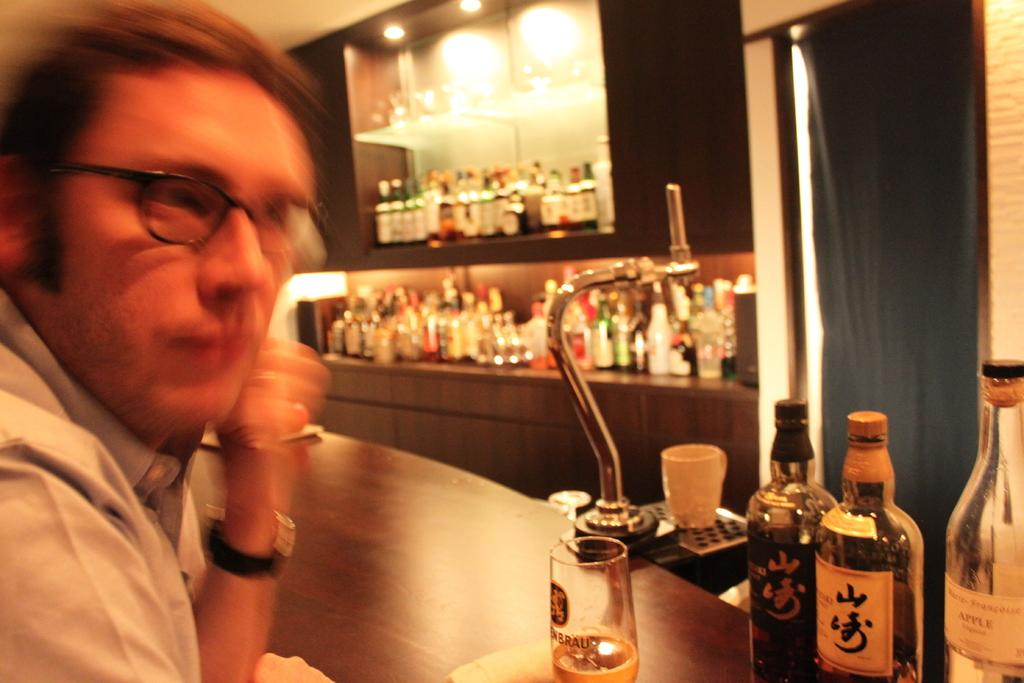What is the person in the image doing? The person is sitting in front of a table. What items can be seen on the table? There are wine bottles and a glass on the table. Are there any other wine bottles visible in the image? Yes, there are wine bottles in the background. What object can be seen in the background of the image? There is a mirror in the background. What type of suit is the doll wearing in the image? There is no doll present in the image, so it is not possible to answer that question. 